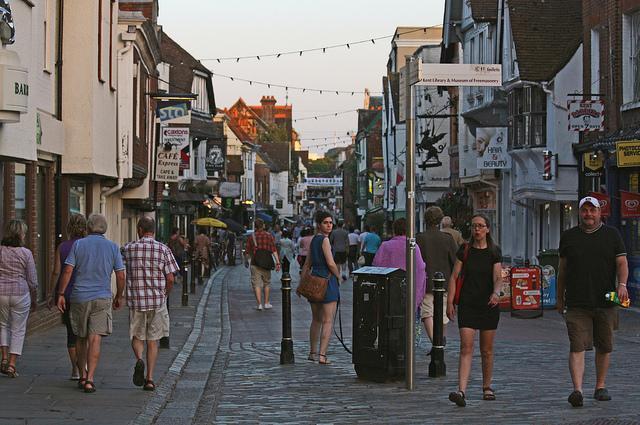What kind of area in town is this?
Indicate the correct response and explain using: 'Answer: answer
Rationale: rationale.'
Options: Shopping area, industrial, residential area, office buildings. Answer: shopping area.
Rationale: This seems to be the case given all of the retailers. 